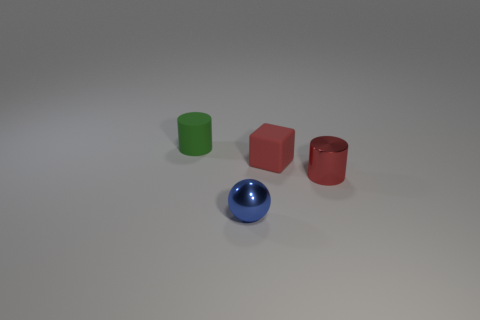Is the red cylinder that is to the right of the tiny green cylinder made of the same material as the small red block?
Keep it short and to the point. No. What material is the tiny thing that is both behind the tiny red shiny thing and to the right of the blue metal ball?
Give a very brief answer. Rubber. What color is the tiny thing that is in front of the tiny metal object that is behind the tiny metal sphere?
Your answer should be very brief. Blue. There is another tiny thing that is the same shape as the small green matte thing; what is it made of?
Keep it short and to the point. Metal. The cylinder that is left of the ball to the right of the small cylinder that is to the left of the red shiny cylinder is what color?
Your answer should be compact. Green. What number of things are cylinders or blocks?
Provide a succinct answer. 3. What number of red rubber things have the same shape as the blue shiny object?
Offer a very short reply. 0. Do the tiny green thing and the cylinder that is right of the small green thing have the same material?
Your response must be concise. No. What is the size of the red thing that is the same material as the sphere?
Give a very brief answer. Small. What is the size of the shiny thing right of the red matte cube?
Make the answer very short. Small. 